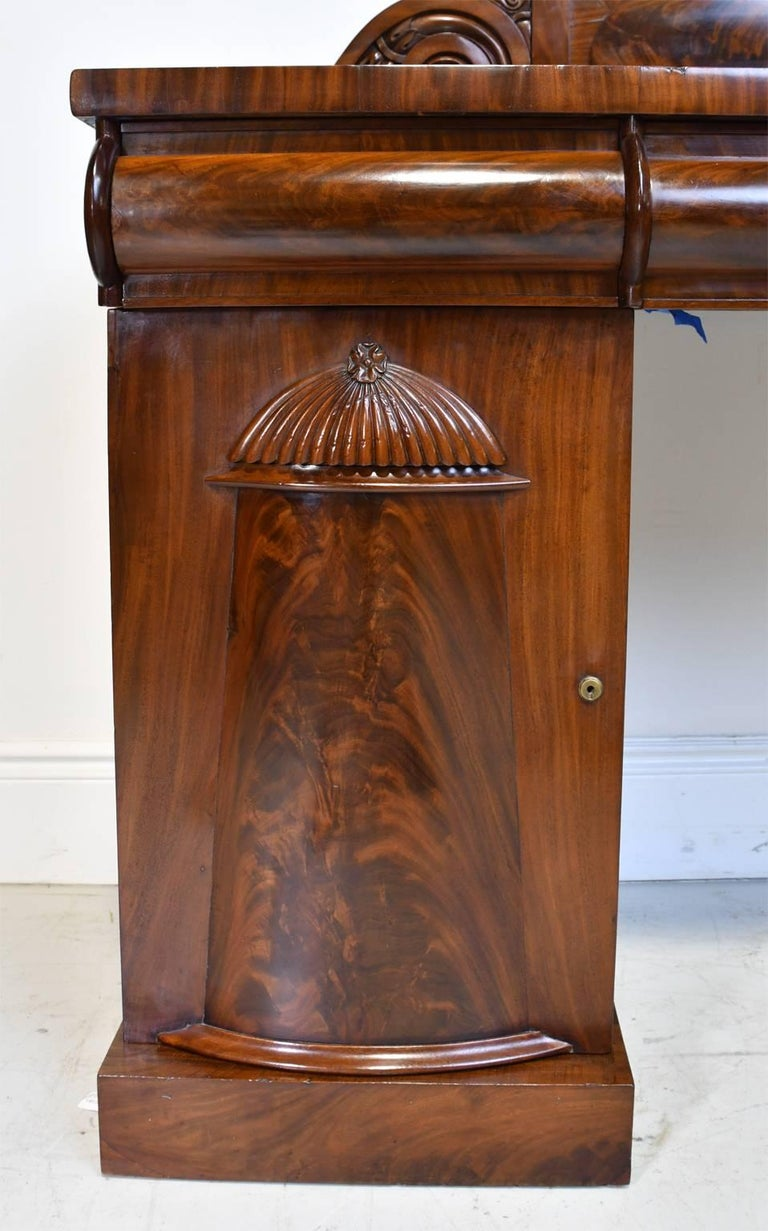What type of wood is used in this furniture, and why is it favored? The furniture is crafted from walnut, a wood prized for its deep, rich grain and durability. Walnut has been a favorite in fine furniture making, especially during periods like the Victorian era, for its ability to achieve a smooth finish and its resistance to warping. The color and texture of walnut wood contribute to its luxurious appearance, making it an ideal choice for statement pieces that are both functional and decorative. 